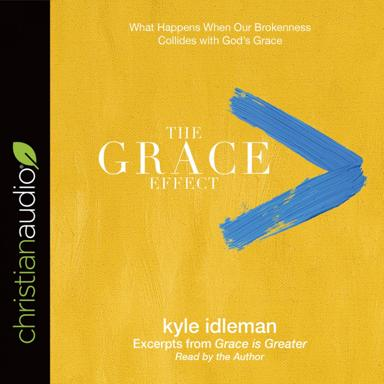Can you tell me more about the author of the book shown in the image? Kyle Idleman is a bestselling author notable for his profound and accessible approach to Christian teachings. He is known for his ability to distill complex theological concepts into practical life lessons that resonate with a broad audience. His work often focuses on grace, redemption, and personal growth in the context of Christian faith. 